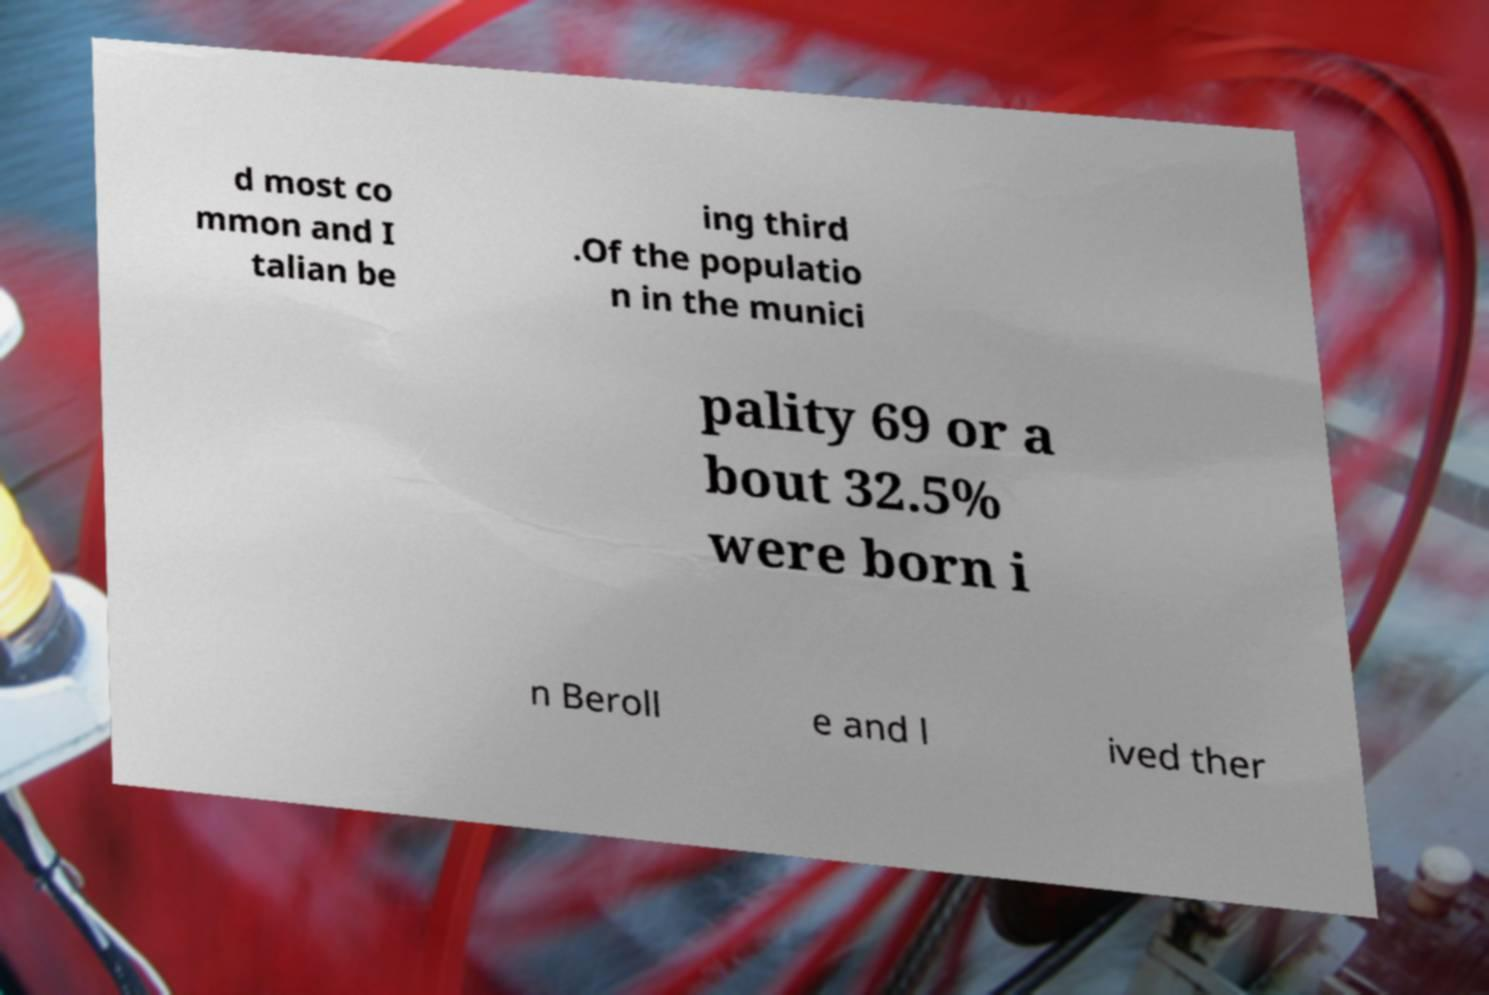What messages or text are displayed in this image? I need them in a readable, typed format. d most co mmon and I talian be ing third .Of the populatio n in the munici pality 69 or a bout 32.5% were born i n Beroll e and l ived ther 